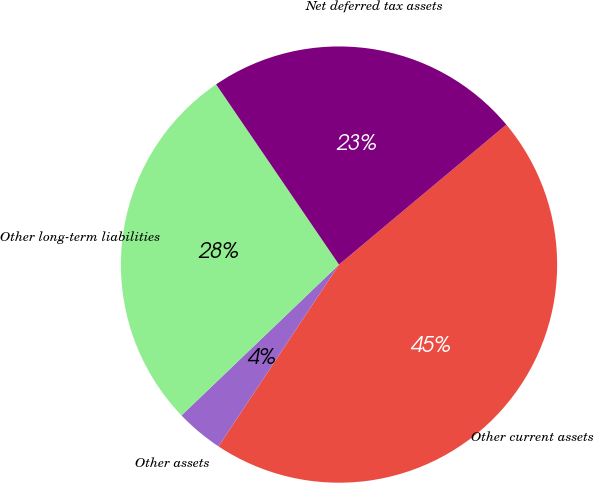<chart> <loc_0><loc_0><loc_500><loc_500><pie_chart><fcel>Other current assets<fcel>Other assets<fcel>Other long-term liabilities<fcel>Net deferred tax assets<nl><fcel>45.4%<fcel>3.53%<fcel>27.63%<fcel>23.44%<nl></chart> 